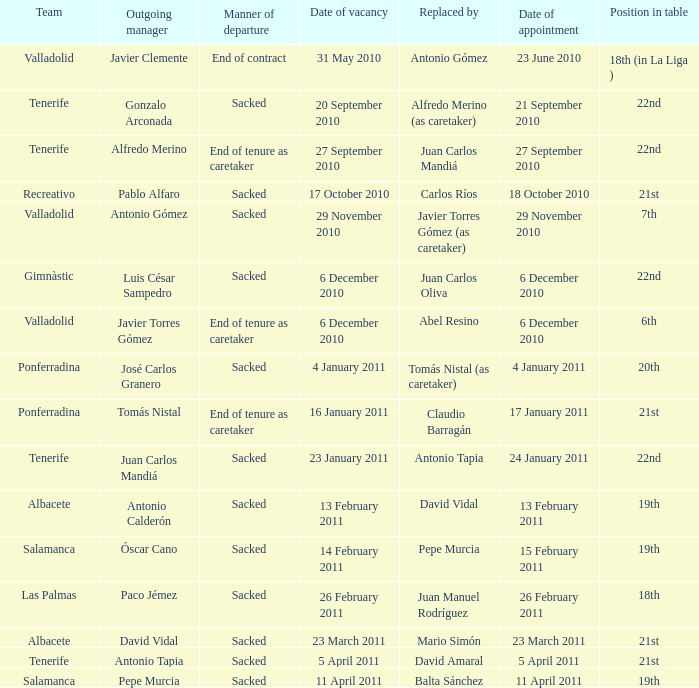What was the way of going for the planned engagement on 21 september 2010? Sacked. 